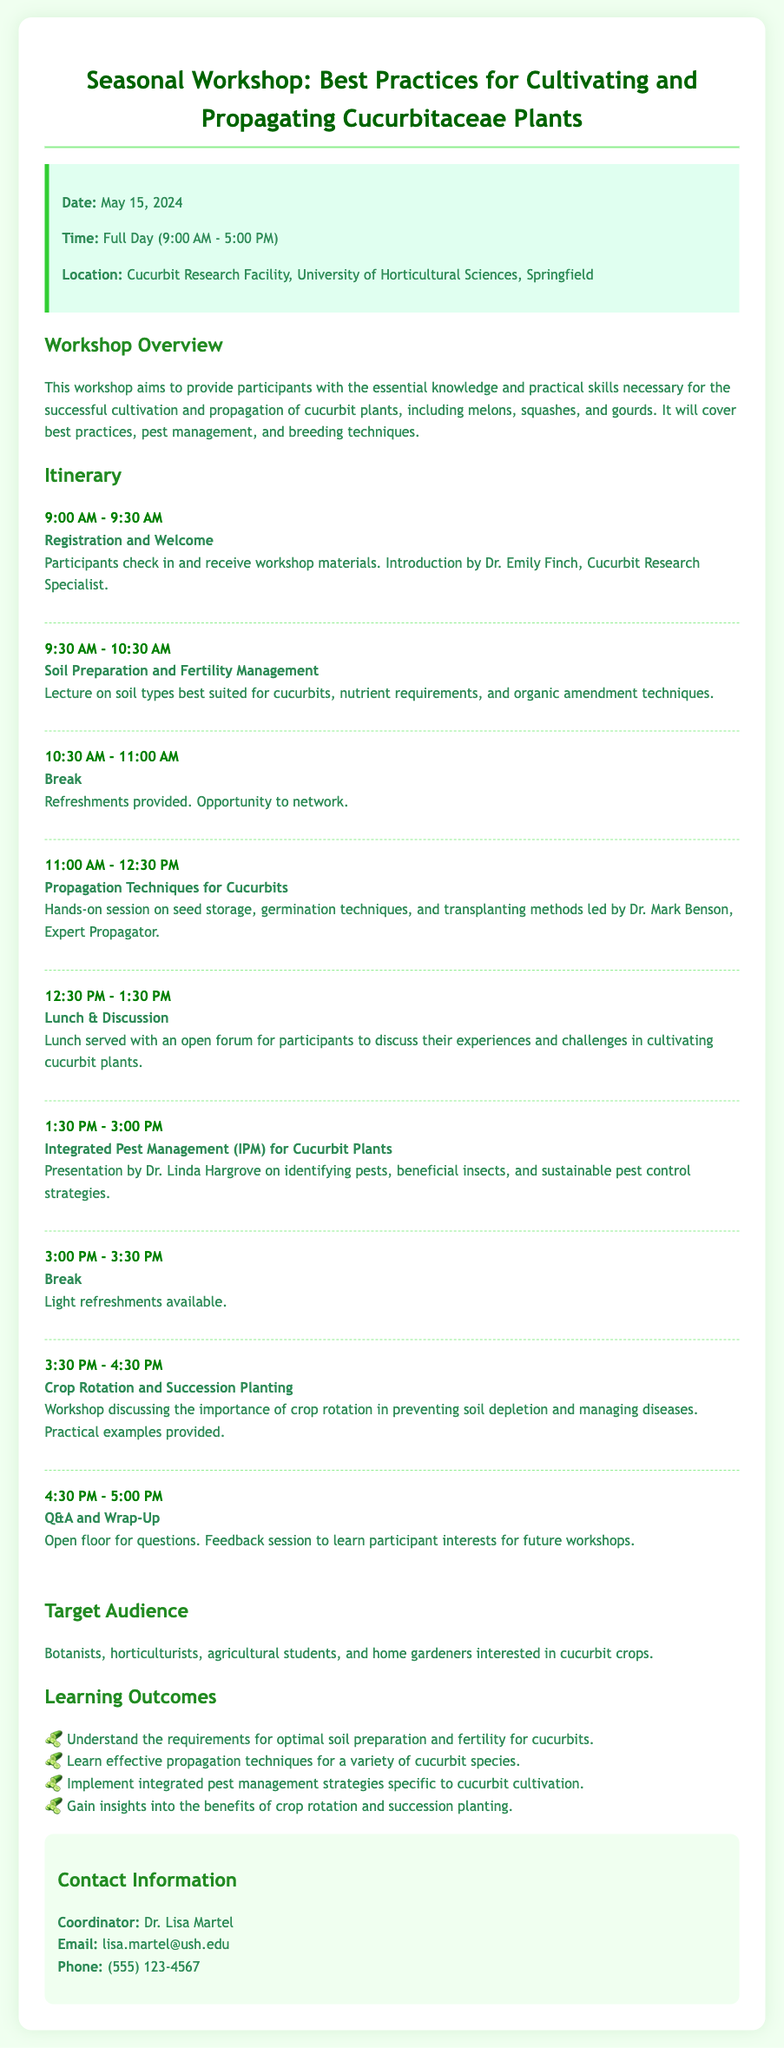What is the date of the workshop? The date of the workshop is clearly stated in the info box section of the document.
Answer: May 15, 2024 Who is the coordinator of the workshop? The contact section at the end of the document specifies the coordinator's name.
Answer: Dr. Lisa Martel What time does the workshop start? The time of the workshop is mentioned in the info box, which lists the schedule.
Answer: 9:00 AM What topic is covered right after the break at 10:30 AM? The itinerary section describes the activities scheduled for each time slot, including what follows the break.
Answer: Propagation Techniques for Cucurbits Which expert is presenting on Integrated Pest Management? The name of the presenter for the Integrated Pest Management session is provided in the itinerary, indicating the relevant information.
Answer: Dr. Linda Hargrove What is the main aim of the workshop? The overview section explains the primary goal of the workshop and what participants will learn.
Answer: Provide essential knowledge and practical skills for cultivating and propagating cucurbit plants What is one of the learning outcomes related to soil? The learning outcomes section specifies the goals participants should achieve regarding soil preparation.
Answer: Understand the requirements for optimal soil preparation and fertility for cucurbits How long is the lunch break? The itinerary indicates the duration of the lunch and discussion segment, which pertains to the timing of the workshop events.
Answer: 1 hour 